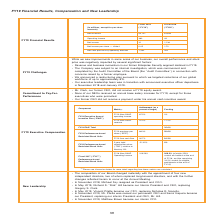According to Nortonlifelock's financial document, How much reduction in global workforce is in the restructuring plan? up to approximately 8%. The document states: "we targeted reductions of our global workforce of up to approximately 8%. • Our executive leadership team was in transition with announced executive o..." Also, What does the table show? FY19 Financial Results. The document states: "FY19 Financial Results, Compensation and New Leadership..." Also, How was overall performance and stock price in FY19? According to the financial document, negatively impacted. The relevant text states: "ness, our overall performance and stock price was negatively impacted by several significant factors: • Revenue and business momentum in our former Enterprise Security s..." Also, can you calculate: How many diluted shares were there in FY19 ? Based on the calculation: (31 millions)/0.05, the result is 620000000. This is based on the information: "Net income per share — diluted 0.05 1.70 Net revenues $4,731 $4,834..." The key data points involved are: 0.05, 31. Also, can you calculate: What is the average net revenue for a Fiscal year? To answer this question, I need to perform calculations using the financial data. The calculation is: (4,731+4,834)/2, which equals 4782.5 (in millions). This is based on the information: "Net revenues $4,731 $4,834 Net revenues $4,731 $4,834..." The key data points involved are: 4,731, 4,834. Also, can you calculate: What is Net income expressed as a percentage of Net revenues for FY19? Based on the calculation: 31/4,731, the result is 0.66 (percentage). This is based on the information: "Net revenues $4,731 $4,834 Net revenues $4,731 $4,834..." The key data points involved are: 31, 4,731. 